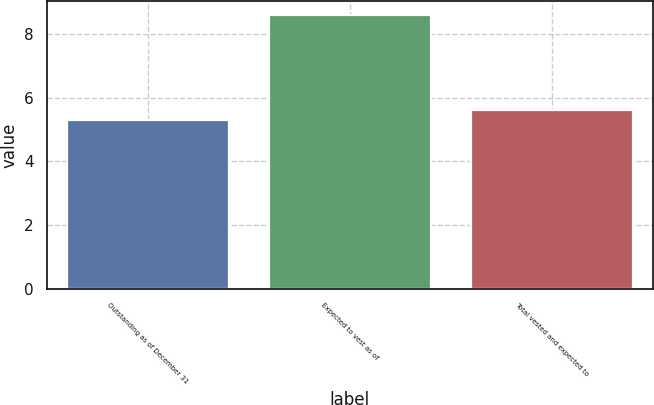Convert chart to OTSL. <chart><loc_0><loc_0><loc_500><loc_500><bar_chart><fcel>Outstanding as of December 31<fcel>Expected to vest as of<fcel>Total vested and expected to<nl><fcel>5.3<fcel>8.6<fcel>5.63<nl></chart> 